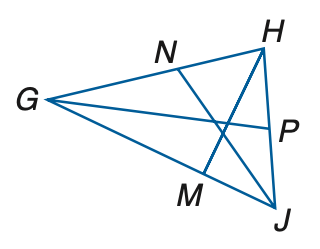Answer the mathemtical geometry problem and directly provide the correct option letter.
Question: In \triangle G H J, H P = 5 x - 16, P J = 3 x + 8, m \angle G J N = 6 y - 3, m \angle N J H = 4 y + 23 and m \angle H M G = 4 z + 14. Find m \angle G J H if J N is an angle bisector.
Choices: A: 60 B: 90 C: 120 D: 150 D 